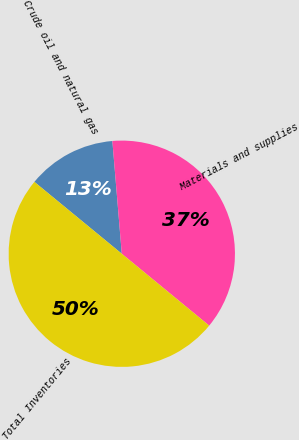<chart> <loc_0><loc_0><loc_500><loc_500><pie_chart><fcel>Crude oil and natural gas<fcel>Materials and supplies<fcel>Total Inventories<nl><fcel>12.72%<fcel>37.28%<fcel>50.0%<nl></chart> 